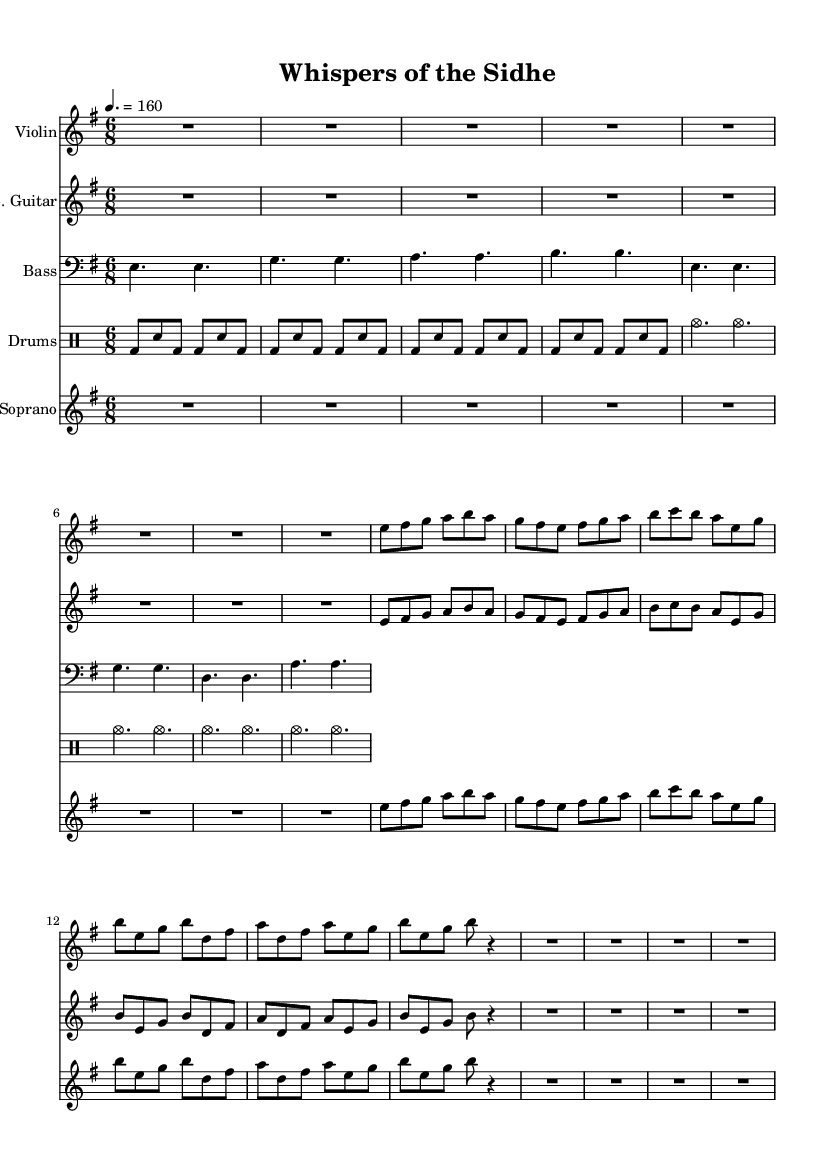What is the key signature of this music? The key signature is indicated by the number of sharps or flats at the beginning of the staff. In this case, there are no sharps or flats, meaning it is in E minor, which is the relative minor of G major.
Answer: E minor What is the time signature of this piece? The time signature is represented by two numbers at the beginning of the music sheet, indicating how many beats are in each measure and what note value constitutes one beat. Here, it shows a 6 over 8, meaning there are six eighth-note beats per measure.
Answer: 6/8 What is the tempo marking for this music? The tempo marking is provided in beats per minute (BPM) within the score. Here, it states "4. = 160," indicating that there are 160 beats per minute when counting quarter notes.
Answer: 160 How many measures are there in the violin part? To determine the number of measures, we can count the distinct groupings of notes and rests within the segment written for the violin. Each set of notes from the beginning to the end of the part indicates a measure. After careful counting, it shows there are a total of 6 measures in the segment.
Answer: 6 What instruments are included in the score? The instruments are identified by their respective staves at the beginning of the score. In this case, the score includes a Violin, Electric Guitar, Bass Guitar, Drums (with a Pitched Drum staff), and Soprano.
Answer: Violin, Electric Guitar, Bass, Drums, Soprano What is the style of this music piece? The piece is characterized by its orchestration and thematic inspiration, drawing elements from black metal and incorporating orchestral textures that echo Celtic folklore and mythological themes. The combination of heavy guitar riffs with orchestral arrangements defines its style.
Answer: Symphonic black metal 